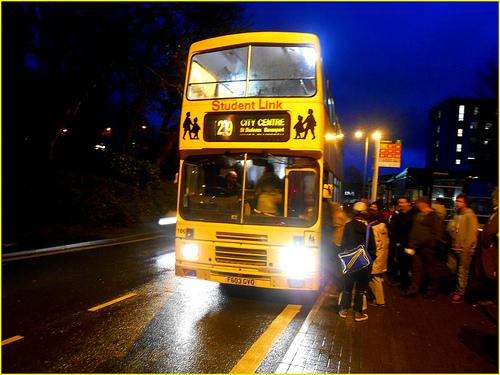Question: what is seen in the picture?
Choices:
A. Bus.
B. Car.
C. Truck.
D. Motorcycle.
Answer with the letter. Answer: A Question: how many bus?
Choices:
A. 2.
B. 1.
C. 3.
D. 4.
Answer with the letter. Answer: B Question: what is the color of the bus?
Choices:
A. White.
B. Red.
C. Yellow.
D. Blue.
Answer with the letter. Answer: C Question: what is the color of the road?
Choices:
A. Yellow.
B. Blue.
C. Red.
D. Grey.
Answer with the letter. Answer: D Question: when is the picture taken?
Choices:
A. Daytime.
B. Sunrise.
C. Sunset.
D. Night time.
Answer with the letter. Answer: D Question: what is the people doing?
Choices:
A. Waiting in line.
B. Riding in the bus.
C. Riding in a car.
D. Getting into the bus.
Answer with the letter. Answer: D Question: where are the yellow lines?
Choices:
A. In the road.
B. On the ground.
C. On the parking lot.
D. On the deck.
Answer with the letter. Answer: A 